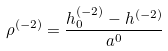<formula> <loc_0><loc_0><loc_500><loc_500>\rho ^ { ( - 2 ) } = \frac { h _ { 0 } ^ { ( - 2 ) } - h ^ { ( - 2 ) } } { a ^ { 0 } }</formula> 